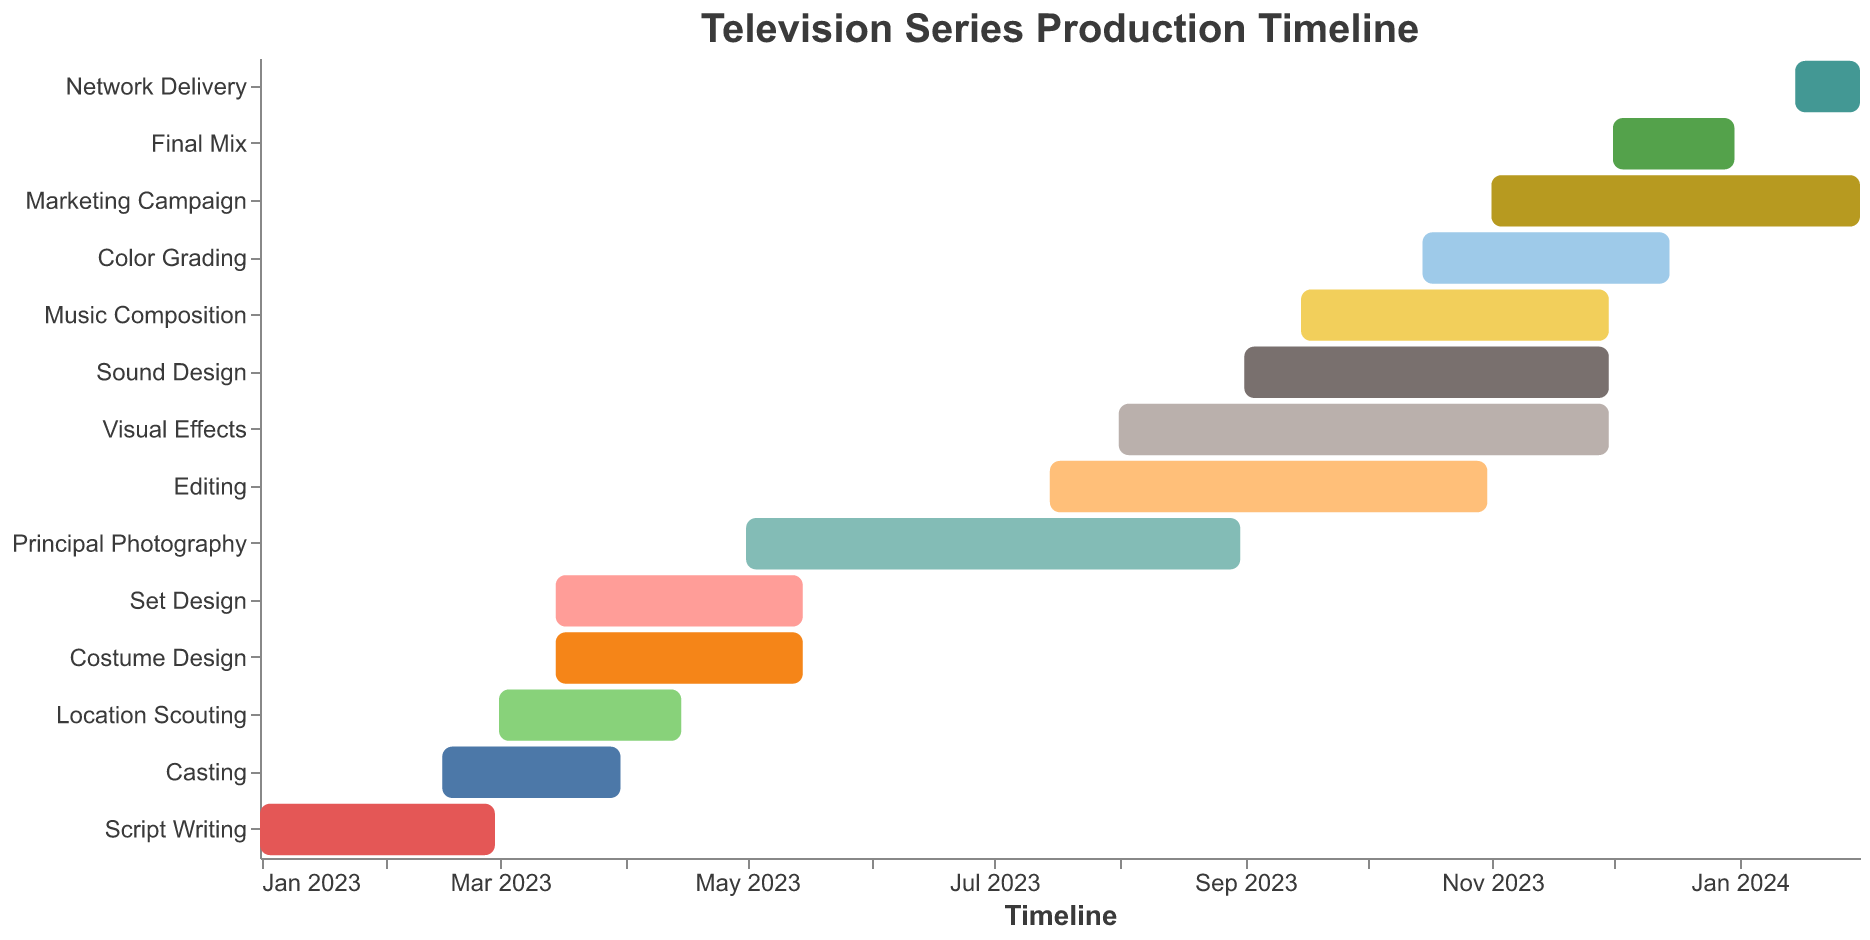What is the duration of the 'Script Writing' phase? The 'Script Writing' phase starts on January 1, 2023, and ends on February 28, 2023. The total duration is calculated by counting the number of days between these two dates, which is 59 days.
Answer: 59 days Which task has the longest duration? To find the task with the longest duration, we need to compare the duration of all the tasks shown in the chart. 'Principal Photography' starts on May 1, 2023, and ends on August 31, 2023. It spans four months, making it the longest task.
Answer: Principal Photography During which months does 'Set Design' take place? 'Set Design' starts on March 15, 2023, and ends on May 15, 2023. Therefore, it spans parts of March, all of April, and part of May.
Answer: March, April, May How many tasks are running concurrently in May 2023? By looking at the start and end dates of each task, we can see that 'Set Design,' 'Costume Design,' 'Principal Photography,' and 'Casting' all overlap within May 2023. Thus, there are four tasks running concurrently.
Answer: Four tasks Does 'Editing' overlap with 'Principal Photography'? If so, for how long? 'Editing' starts on July 15, 2023 and 'Principal Photography' ends on August 31, 2023. Both tasks overlap from July 15, 2023, to August 31, 2023, which is 48 days.
Answer: Yes, 48 days Are there any tasks that begin while the 'Marketing Campaign' is ongoing? The 'Marketing Campaign' starts on November 1, 2023, and ends on January 31, 2024. To determine if any tasks start during this period, we see that 'Network Delivery' begins on January 15, 2024, during the 'Marketing Campaign'.
Answer: Yes, Network Delivery When does the 'Final Mix' phase occur? The 'Final Mix' phase starts on December 1, 2023, and ends on December 31, 2023. Therefore, it spans the entire month of December 2023.
Answer: December 2023 Which tasks extend into the year 2024? Tasks extending into 2024 based on their end dates are the 'Marketing Campaign,' which ends on January 31, 2024, and 'Network Delivery,' which also ends on January 31, 2024.
Answer: Marketing Campaign, Network Delivery 